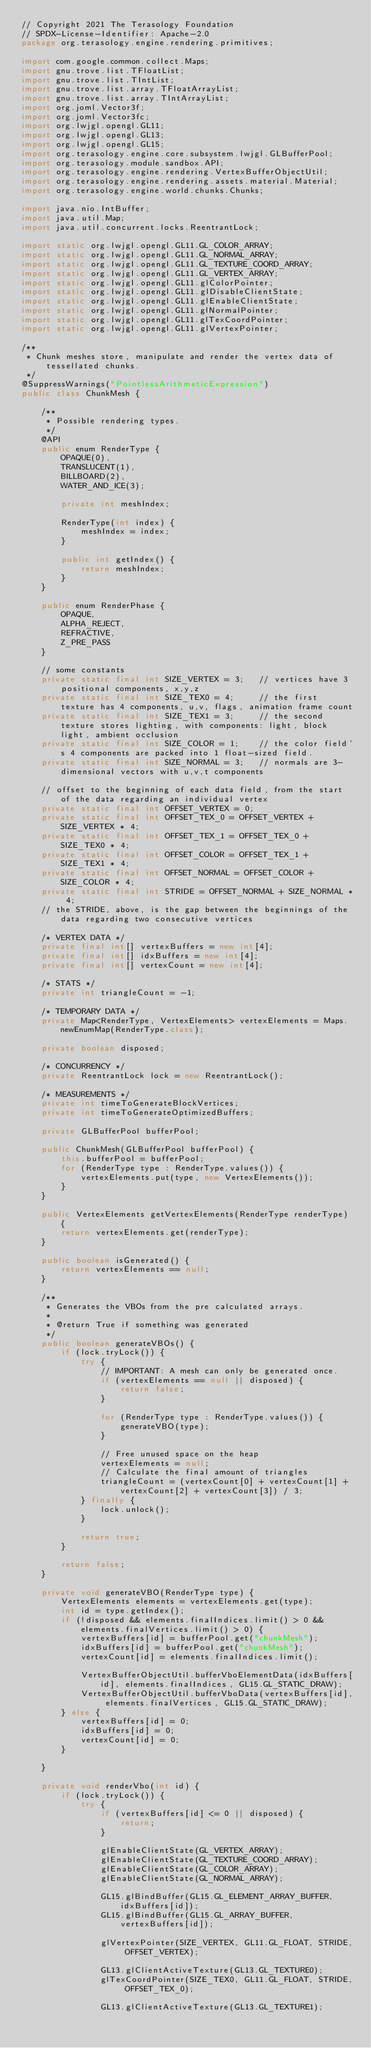Convert code to text. <code><loc_0><loc_0><loc_500><loc_500><_Java_>// Copyright 2021 The Terasology Foundation
// SPDX-License-Identifier: Apache-2.0
package org.terasology.engine.rendering.primitives;

import com.google.common.collect.Maps;
import gnu.trove.list.TFloatList;
import gnu.trove.list.TIntList;
import gnu.trove.list.array.TFloatArrayList;
import gnu.trove.list.array.TIntArrayList;
import org.joml.Vector3f;
import org.joml.Vector3fc;
import org.lwjgl.opengl.GL11;
import org.lwjgl.opengl.GL13;
import org.lwjgl.opengl.GL15;
import org.terasology.engine.core.subsystem.lwjgl.GLBufferPool;
import org.terasology.module.sandbox.API;
import org.terasology.engine.rendering.VertexBufferObjectUtil;
import org.terasology.engine.rendering.assets.material.Material;
import org.terasology.engine.world.chunks.Chunks;

import java.nio.IntBuffer;
import java.util.Map;
import java.util.concurrent.locks.ReentrantLock;

import static org.lwjgl.opengl.GL11.GL_COLOR_ARRAY;
import static org.lwjgl.opengl.GL11.GL_NORMAL_ARRAY;
import static org.lwjgl.opengl.GL11.GL_TEXTURE_COORD_ARRAY;
import static org.lwjgl.opengl.GL11.GL_VERTEX_ARRAY;
import static org.lwjgl.opengl.GL11.glColorPointer;
import static org.lwjgl.opengl.GL11.glDisableClientState;
import static org.lwjgl.opengl.GL11.glEnableClientState;
import static org.lwjgl.opengl.GL11.glNormalPointer;
import static org.lwjgl.opengl.GL11.glTexCoordPointer;
import static org.lwjgl.opengl.GL11.glVertexPointer;

/**
 * Chunk meshes store, manipulate and render the vertex data of tessellated chunks.
 */
@SuppressWarnings("PointlessArithmeticExpression")
public class ChunkMesh {

    /**
     * Possible rendering types.
     */
    @API
    public enum RenderType {
        OPAQUE(0),
        TRANSLUCENT(1),
        BILLBOARD(2),
        WATER_AND_ICE(3);

        private int meshIndex;

        RenderType(int index) {
            meshIndex = index;
        }

        public int getIndex() {
            return meshIndex;
        }
    }

    public enum RenderPhase {
        OPAQUE,
        ALPHA_REJECT,
        REFRACTIVE,
        Z_PRE_PASS
    }

    // some constants
    private static final int SIZE_VERTEX = 3;   // vertices have 3 positional components, x,y,z
    private static final int SIZE_TEX0 = 4;     // the first texture has 4 components, u,v, flags, animation frame count
    private static final int SIZE_TEX1 = 3;     // the second texture stores lighting, with components: light, block light, ambient occlusion
    private static final int SIZE_COLOR = 1;    // the color field's 4 components are packed into 1 float-sized field.
    private static final int SIZE_NORMAL = 3;   // normals are 3-dimensional vectors with u,v,t components

    // offset to the beginning of each data field, from the start of the data regarding an individual vertex
    private static final int OFFSET_VERTEX = 0;
    private static final int OFFSET_TEX_0 = OFFSET_VERTEX + SIZE_VERTEX * 4;
    private static final int OFFSET_TEX_1 = OFFSET_TEX_0 + SIZE_TEX0 * 4;
    private static final int OFFSET_COLOR = OFFSET_TEX_1 + SIZE_TEX1 * 4;
    private static final int OFFSET_NORMAL = OFFSET_COLOR + SIZE_COLOR * 4;
    private static final int STRIDE = OFFSET_NORMAL + SIZE_NORMAL * 4;
    // the STRIDE, above, is the gap between the beginnings of the data regarding two consecutive vertices

    /* VERTEX DATA */
    private final int[] vertexBuffers = new int[4];
    private final int[] idxBuffers = new int[4];
    private final int[] vertexCount = new int[4];

    /* STATS */
    private int triangleCount = -1;

    /* TEMPORARY DATA */
    private Map<RenderType, VertexElements> vertexElements = Maps.newEnumMap(RenderType.class);

    private boolean disposed;

    /* CONCURRENCY */
    private ReentrantLock lock = new ReentrantLock();

    /* MEASUREMENTS */
    private int timeToGenerateBlockVertices;
    private int timeToGenerateOptimizedBuffers;

    private GLBufferPool bufferPool;

    public ChunkMesh(GLBufferPool bufferPool) {
        this.bufferPool = bufferPool;
        for (RenderType type : RenderType.values()) {
            vertexElements.put(type, new VertexElements());
        }
    }

    public VertexElements getVertexElements(RenderType renderType) {
        return vertexElements.get(renderType);
    }

    public boolean isGenerated() {
        return vertexElements == null;
    }

    /**
     * Generates the VBOs from the pre calculated arrays.
     *
     * @return True if something was generated
     */
    public boolean generateVBOs() {
        if (lock.tryLock()) {
            try {
                // IMPORTANT: A mesh can only be generated once.
                if (vertexElements == null || disposed) {
                    return false;
                }

                for (RenderType type : RenderType.values()) {
                    generateVBO(type);
                }

                // Free unused space on the heap
                vertexElements = null;
                // Calculate the final amount of triangles
                triangleCount = (vertexCount[0] + vertexCount[1] + vertexCount[2] + vertexCount[3]) / 3;
            } finally {
                lock.unlock();
            }

            return true;
        }

        return false;
    }

    private void generateVBO(RenderType type) {
        VertexElements elements = vertexElements.get(type);
        int id = type.getIndex();
        if (!disposed && elements.finalIndices.limit() > 0 && elements.finalVertices.limit() > 0) {
            vertexBuffers[id] = bufferPool.get("chunkMesh");
            idxBuffers[id] = bufferPool.get("chunkMesh");
            vertexCount[id] = elements.finalIndices.limit();

            VertexBufferObjectUtil.bufferVboElementData(idxBuffers[id], elements.finalIndices, GL15.GL_STATIC_DRAW);
            VertexBufferObjectUtil.bufferVboData(vertexBuffers[id], elements.finalVertices, GL15.GL_STATIC_DRAW);
        } else {
            vertexBuffers[id] = 0;
            idxBuffers[id] = 0;
            vertexCount[id] = 0;
        }

    }

    private void renderVbo(int id) {
        if (lock.tryLock()) {
            try {
                if (vertexBuffers[id] <= 0 || disposed) {
                    return;
                }

                glEnableClientState(GL_VERTEX_ARRAY);
                glEnableClientState(GL_TEXTURE_COORD_ARRAY);
                glEnableClientState(GL_COLOR_ARRAY);
                glEnableClientState(GL_NORMAL_ARRAY);

                GL15.glBindBuffer(GL15.GL_ELEMENT_ARRAY_BUFFER, idxBuffers[id]);
                GL15.glBindBuffer(GL15.GL_ARRAY_BUFFER, vertexBuffers[id]);

                glVertexPointer(SIZE_VERTEX, GL11.GL_FLOAT, STRIDE, OFFSET_VERTEX);

                GL13.glClientActiveTexture(GL13.GL_TEXTURE0);
                glTexCoordPointer(SIZE_TEX0, GL11.GL_FLOAT, STRIDE, OFFSET_TEX_0);

                GL13.glClientActiveTexture(GL13.GL_TEXTURE1);</code> 